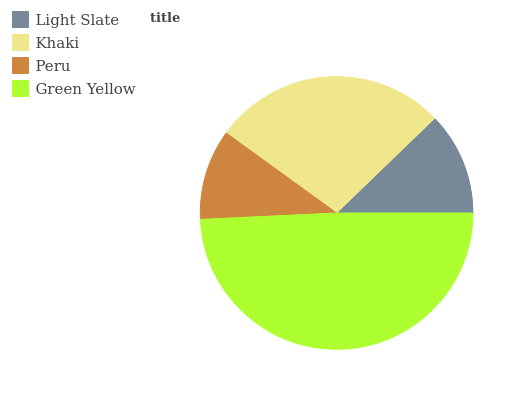Is Peru the minimum?
Answer yes or no. Yes. Is Green Yellow the maximum?
Answer yes or no. Yes. Is Khaki the minimum?
Answer yes or no. No. Is Khaki the maximum?
Answer yes or no. No. Is Khaki greater than Light Slate?
Answer yes or no. Yes. Is Light Slate less than Khaki?
Answer yes or no. Yes. Is Light Slate greater than Khaki?
Answer yes or no. No. Is Khaki less than Light Slate?
Answer yes or no. No. Is Khaki the high median?
Answer yes or no. Yes. Is Light Slate the low median?
Answer yes or no. Yes. Is Green Yellow the high median?
Answer yes or no. No. Is Green Yellow the low median?
Answer yes or no. No. 